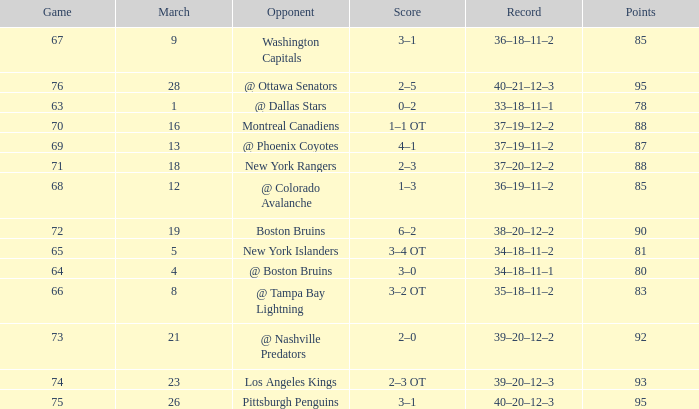Which Game is the highest one that has Points smaller than 92, and a Score of 1–3? 68.0. Write the full table. {'header': ['Game', 'March', 'Opponent', 'Score', 'Record', 'Points'], 'rows': [['67', '9', 'Washington Capitals', '3–1', '36–18–11–2', '85'], ['76', '28', '@ Ottawa Senators', '2–5', '40–21–12–3', '95'], ['63', '1', '@ Dallas Stars', '0–2', '33–18–11–1', '78'], ['70', '16', 'Montreal Canadiens', '1–1 OT', '37–19–12–2', '88'], ['69', '13', '@ Phoenix Coyotes', '4–1', '37–19–11–2', '87'], ['71', '18', 'New York Rangers', '2–3', '37–20–12–2', '88'], ['68', '12', '@ Colorado Avalanche', '1–3', '36–19–11–2', '85'], ['72', '19', 'Boston Bruins', '6–2', '38–20–12–2', '90'], ['65', '5', 'New York Islanders', '3–4 OT', '34–18–11–2', '81'], ['64', '4', '@ Boston Bruins', '3–0', '34–18–11–1', '80'], ['66', '8', '@ Tampa Bay Lightning', '3–2 OT', '35–18–11–2', '83'], ['73', '21', '@ Nashville Predators', '2–0', '39–20–12–2', '92'], ['74', '23', 'Los Angeles Kings', '2–3 OT', '39–20–12–3', '93'], ['75', '26', 'Pittsburgh Penguins', '3–1', '40–20–12–3', '95']]} 